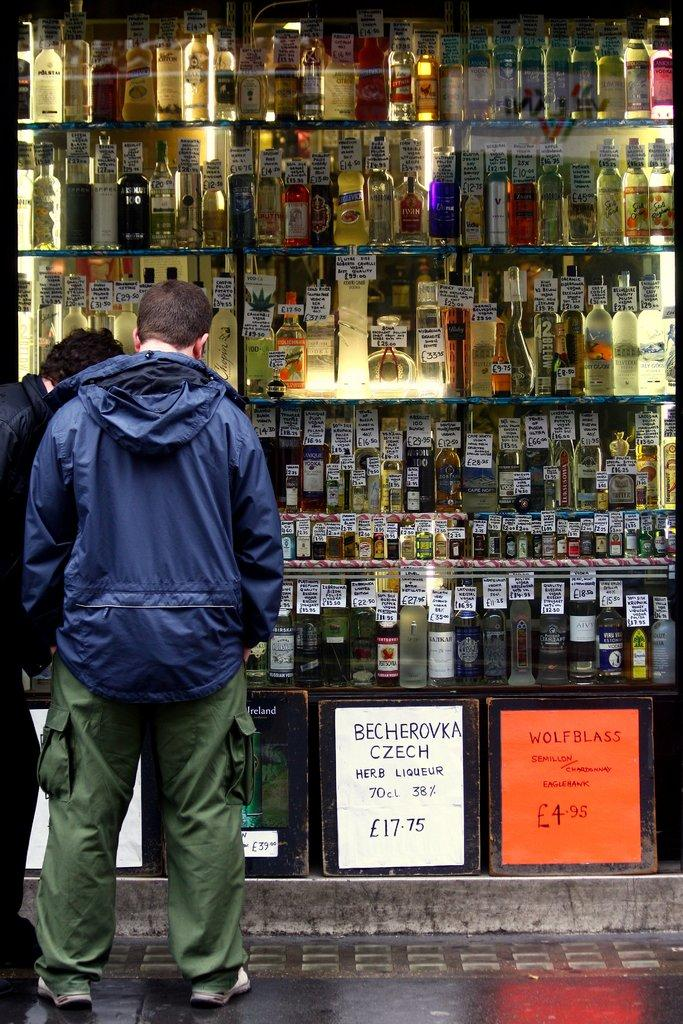<image>
Offer a succinct explanation of the picture presented. Man looking inside a liquor store with a sign in front saying Becherovka Czech. 